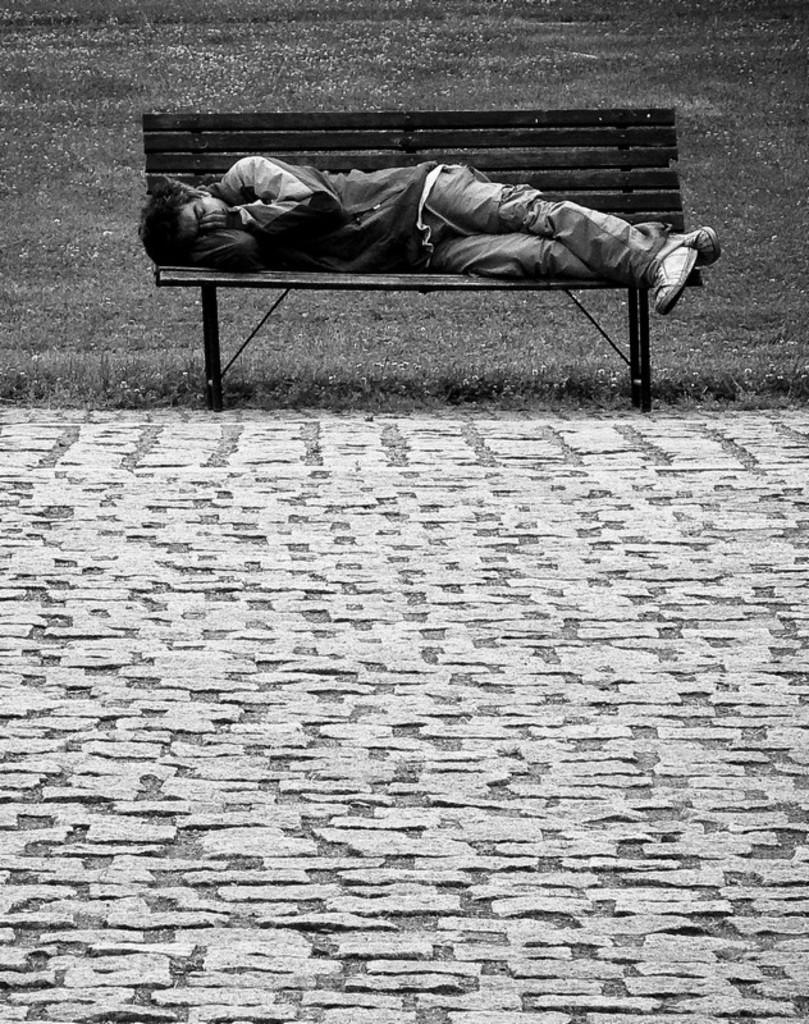What is the person in the image doing? The person is lying on a bench in the image. What type of surface is visible beneath the person? There is grass visible in the image. What kind of feature can be seen in the image that might be used for walking? There is a path in the image. What type of approval is the person seeking from the slave in the image? There is no slave or indication of seeking approval in the image; it only shows a person lying on a bench with grass and a path nearby. 